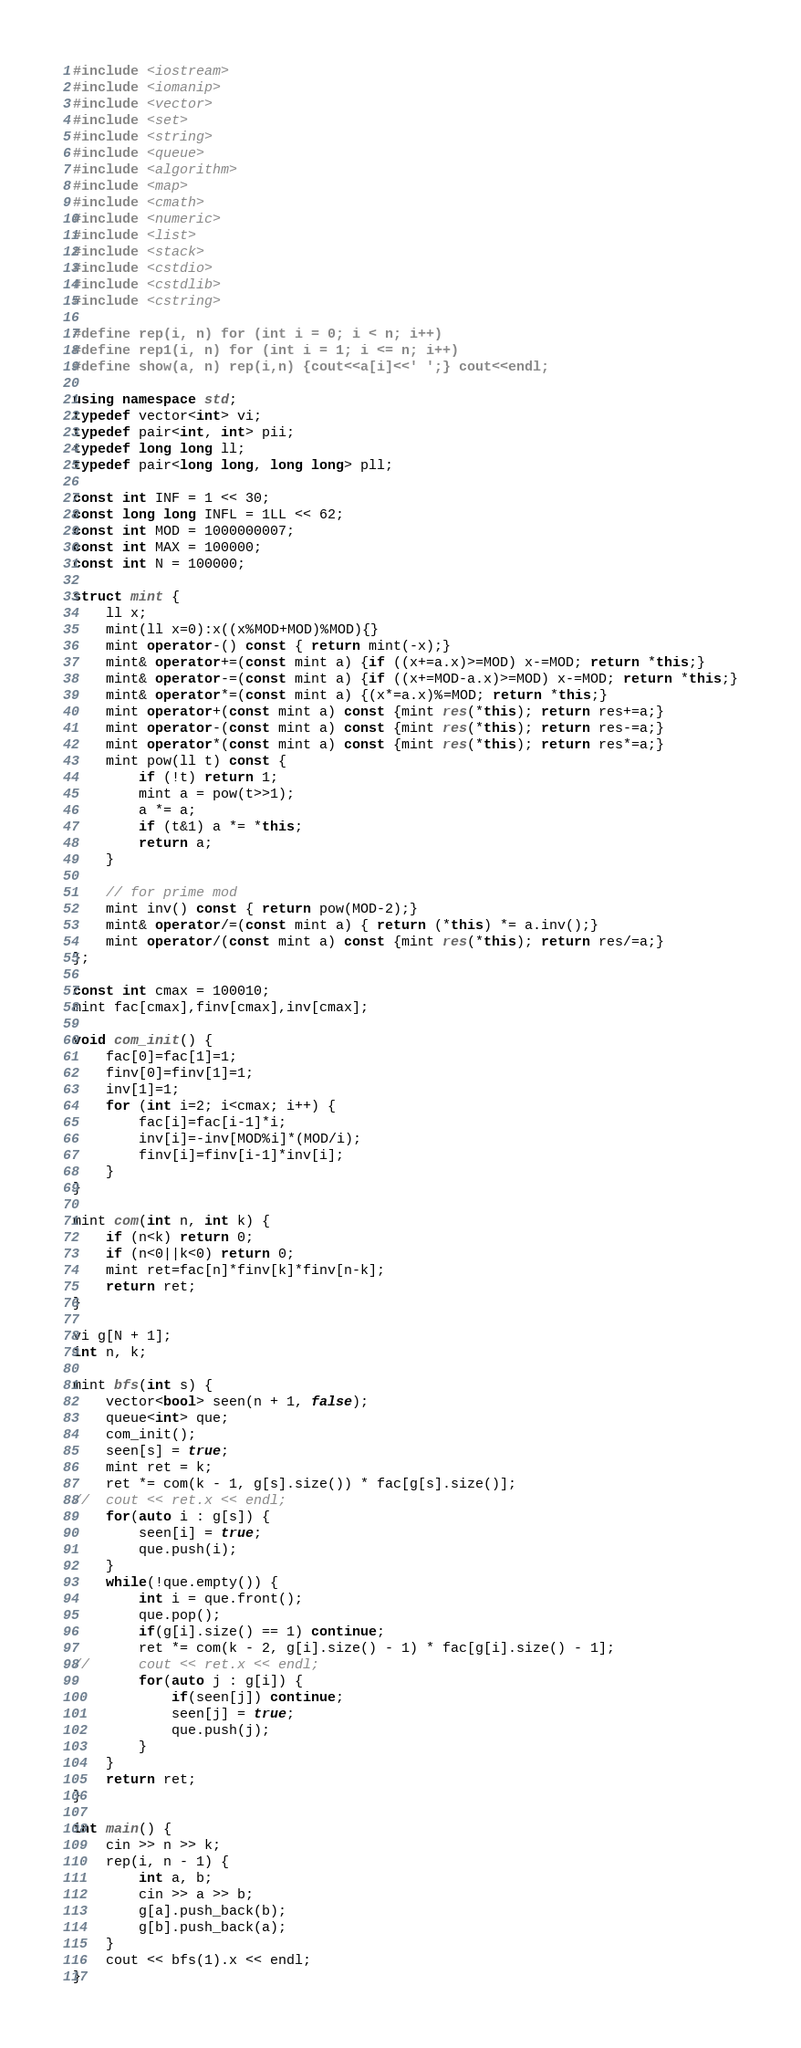Convert code to text. <code><loc_0><loc_0><loc_500><loc_500><_C++_>#include <iostream>
#include <iomanip>
#include <vector>
#include <set>
#include <string>
#include <queue>
#include <algorithm>
#include <map>
#include <cmath>
#include <numeric>
#include <list>
#include <stack>
#include <cstdio>
#include <cstdlib>
#include <cstring>

#define rep(i, n) for (int i = 0; i < n; i++)
#define rep1(i, n) for (int i = 1; i <= n; i++)
#define show(a, n) rep(i,n) {cout<<a[i]<<' ';} cout<<endl;

using namespace std;
typedef vector<int> vi;
typedef pair<int, int> pii;
typedef long long ll;
typedef pair<long long, long long> pll;

const int INF = 1 << 30;
const long long INFL = 1LL << 62;
const int MOD = 1000000007;
const int MAX = 100000;
const int N = 100000;

struct mint {
    ll x;
    mint(ll x=0):x((x%MOD+MOD)%MOD){}
    mint operator-() const { return mint(-x);}
    mint& operator+=(const mint a) {if ((x+=a.x)>=MOD) x-=MOD; return *this;}
    mint& operator-=(const mint a) {if ((x+=MOD-a.x)>=MOD) x-=MOD; return *this;}
    mint& operator*=(const mint a) {(x*=a.x)%=MOD; return *this;}
    mint operator+(const mint a) const {mint res(*this); return res+=a;}
    mint operator-(const mint a) const {mint res(*this); return res-=a;}
    mint operator*(const mint a) const {mint res(*this); return res*=a;}
    mint pow(ll t) const {
        if (!t) return 1;
        mint a = pow(t>>1);
        a *= a;
        if (t&1) a *= *this;
        return a;
    }

    // for prime mod
    mint inv() const { return pow(MOD-2);}
    mint& operator/=(const mint a) { return (*this) *= a.inv();}
    mint operator/(const mint a) const {mint res(*this); return res/=a;}
};

const int cmax = 100010;
mint fac[cmax],finv[cmax],inv[cmax];

void com_init() {
    fac[0]=fac[1]=1;
    finv[0]=finv[1]=1;
    inv[1]=1;
    for (int i=2; i<cmax; i++) {
        fac[i]=fac[i-1]*i;
        inv[i]=-inv[MOD%i]*(MOD/i);
        finv[i]=finv[i-1]*inv[i];
    }
}

mint com(int n, int k) {
    if (n<k) return 0;
    if (n<0||k<0) return 0;
    mint ret=fac[n]*finv[k]*finv[n-k];
    return ret;
}

vi g[N + 1];
int n, k;

mint bfs(int s) {
	vector<bool> seen(n + 1, false);
	queue<int> que;
	com_init();
	seen[s] = true;
	mint ret = k;
	ret *= com(k - 1, g[s].size()) * fac[g[s].size()];
//	cout << ret.x << endl;
	for(auto i : g[s]) {
		seen[i] = true;
		que.push(i);
	}
	while(!que.empty()) {
		int i = que.front();
		que.pop();
		if(g[i].size() == 1) continue;
		ret *= com(k - 2, g[i].size() - 1) * fac[g[i].size() - 1];
//		cout << ret.x << endl;
		for(auto j : g[i]) {
			if(seen[j]) continue;
			seen[j] = true;
			que.push(j);
		}
	}
	return ret;
}

int main() {
	cin >> n >> k;
	rep(i, n - 1) {
		int a, b;
		cin >> a >> b;
		g[a].push_back(b);
		g[b].push_back(a);
	}
	cout << bfs(1).x << endl;
}
</code> 